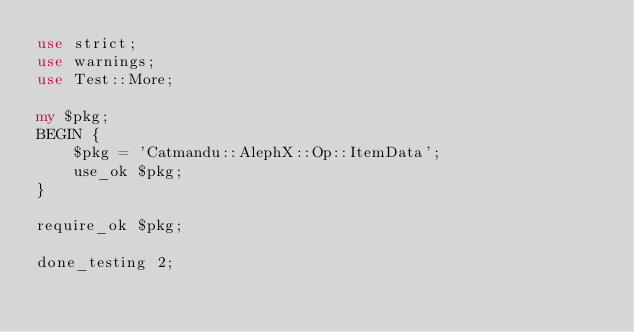<code> <loc_0><loc_0><loc_500><loc_500><_Perl_>use strict;
use warnings;
use Test::More;

my $pkg;
BEGIN {
    $pkg = 'Catmandu::AlephX::Op::ItemData';
    use_ok $pkg;
}

require_ok $pkg;

done_testing 2;
</code> 